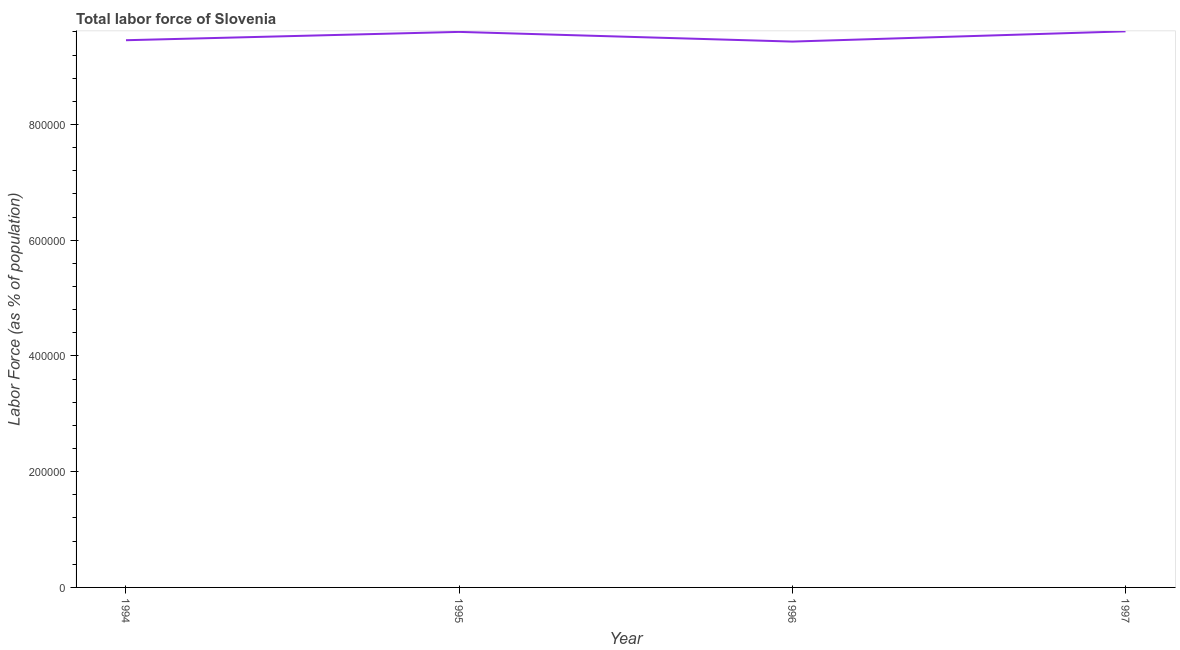What is the total labor force in 1995?
Ensure brevity in your answer.  9.60e+05. Across all years, what is the maximum total labor force?
Provide a short and direct response. 9.61e+05. Across all years, what is the minimum total labor force?
Offer a very short reply. 9.43e+05. In which year was the total labor force maximum?
Your response must be concise. 1997. In which year was the total labor force minimum?
Keep it short and to the point. 1996. What is the sum of the total labor force?
Give a very brief answer. 3.81e+06. What is the difference between the total labor force in 1994 and 1995?
Provide a succinct answer. -1.44e+04. What is the average total labor force per year?
Provide a succinct answer. 9.53e+05. What is the median total labor force?
Provide a succinct answer. 9.53e+05. Do a majority of the years between 1996 and 1997 (inclusive) have total labor force greater than 680000 %?
Offer a terse response. Yes. What is the ratio of the total labor force in 1995 to that in 1997?
Offer a terse response. 1. Is the difference between the total labor force in 1994 and 1997 greater than the difference between any two years?
Your answer should be very brief. No. What is the difference between the highest and the second highest total labor force?
Give a very brief answer. 954. What is the difference between the highest and the lowest total labor force?
Provide a succinct answer. 1.77e+04. In how many years, is the total labor force greater than the average total labor force taken over all years?
Your answer should be compact. 2. Does the total labor force monotonically increase over the years?
Offer a terse response. No. How many lines are there?
Your response must be concise. 1. How many years are there in the graph?
Offer a very short reply. 4. Does the graph contain any zero values?
Keep it short and to the point. No. Does the graph contain grids?
Give a very brief answer. No. What is the title of the graph?
Your response must be concise. Total labor force of Slovenia. What is the label or title of the Y-axis?
Provide a short and direct response. Labor Force (as % of population). What is the Labor Force (as % of population) in 1994?
Your response must be concise. 9.46e+05. What is the Labor Force (as % of population) in 1995?
Keep it short and to the point. 9.60e+05. What is the Labor Force (as % of population) in 1996?
Offer a very short reply. 9.43e+05. What is the Labor Force (as % of population) in 1997?
Your response must be concise. 9.61e+05. What is the difference between the Labor Force (as % of population) in 1994 and 1995?
Offer a very short reply. -1.44e+04. What is the difference between the Labor Force (as % of population) in 1994 and 1996?
Your answer should be very brief. 2348. What is the difference between the Labor Force (as % of population) in 1994 and 1997?
Offer a terse response. -1.53e+04. What is the difference between the Labor Force (as % of population) in 1995 and 1996?
Offer a very short reply. 1.67e+04. What is the difference between the Labor Force (as % of population) in 1995 and 1997?
Your response must be concise. -954. What is the difference between the Labor Force (as % of population) in 1996 and 1997?
Your answer should be compact. -1.77e+04. What is the ratio of the Labor Force (as % of population) in 1994 to that in 1995?
Keep it short and to the point. 0.98. What is the ratio of the Labor Force (as % of population) in 1994 to that in 1996?
Offer a terse response. 1. What is the ratio of the Labor Force (as % of population) in 1995 to that in 1996?
Make the answer very short. 1.02. What is the ratio of the Labor Force (as % of population) in 1995 to that in 1997?
Ensure brevity in your answer.  1. 